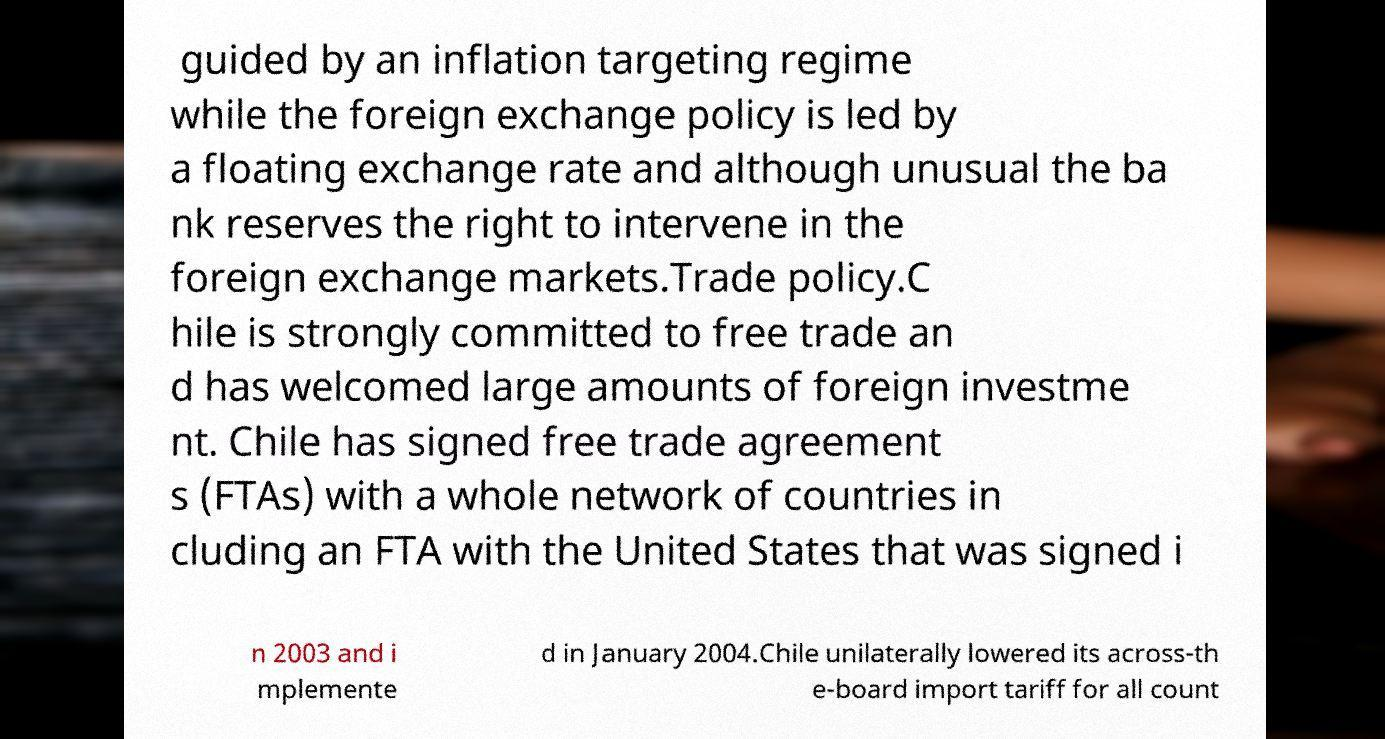Please read and relay the text visible in this image. What does it say? guided by an inflation targeting regime while the foreign exchange policy is led by a floating exchange rate and although unusual the ba nk reserves the right to intervene in the foreign exchange markets.Trade policy.C hile is strongly committed to free trade an d has welcomed large amounts of foreign investme nt. Chile has signed free trade agreement s (FTAs) with a whole network of countries in cluding an FTA with the United States that was signed i n 2003 and i mplemente d in January 2004.Chile unilaterally lowered its across-th e-board import tariff for all count 